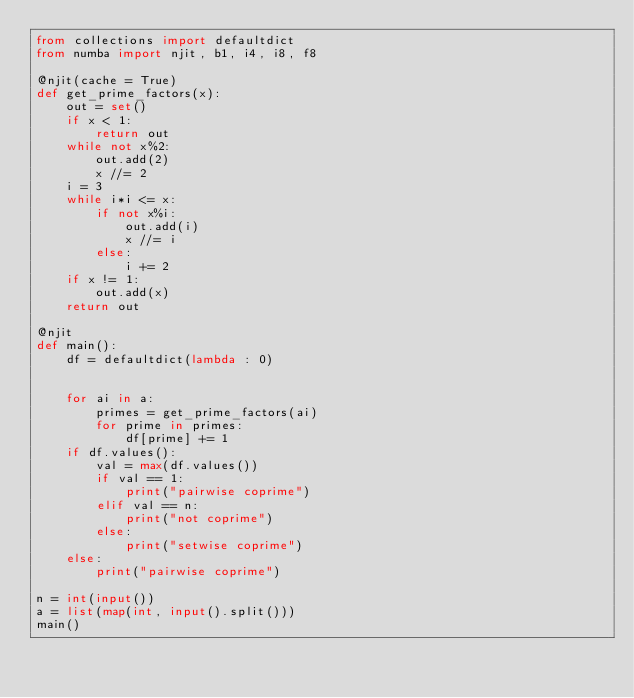Convert code to text. <code><loc_0><loc_0><loc_500><loc_500><_Python_>from collections import defaultdict
from numba import njit, b1, i4, i8, f8

@njit(cache = True)
def get_prime_factors(x):
    out = set()
    if x < 1:
        return out
    while not x%2:
        out.add(2)
        x //= 2
    i = 3
    while i*i <= x:
        if not x%i:
            out.add(i)
            x //= i
        else:
            i += 2
    if x != 1:
        out.add(x)
    return out

@njit
def main():
    df = defaultdict(lambda : 0)
    
    
    for ai in a:
        primes = get_prime_factors(ai)
        for prime in primes:
            df[prime] += 1
    if df.values():
        val = max(df.values())
        if val == 1:
            print("pairwise coprime")
        elif val == n:
            print("not coprime")
        else:
            print("setwise coprime")
    else:
        print("pairwise coprime")

n = int(input())
a = list(map(int, input().split()))
main()
</code> 